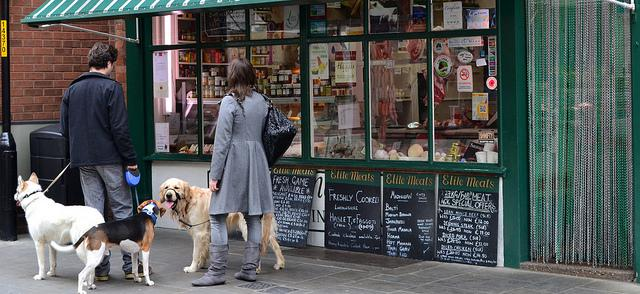What type of animals are shown? dogs 